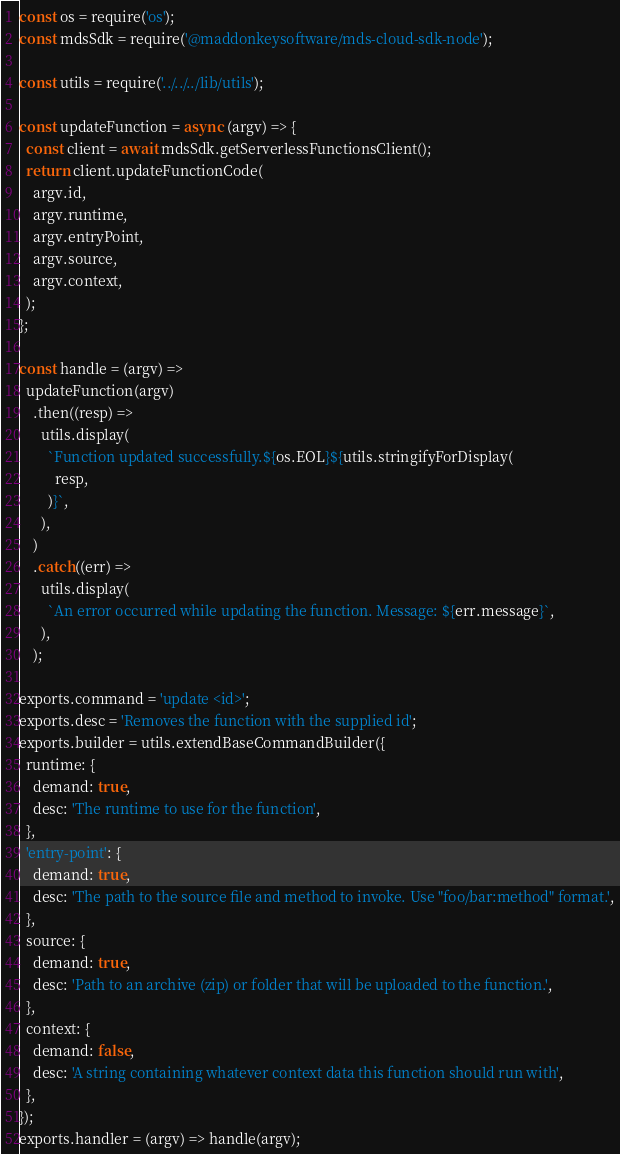<code> <loc_0><loc_0><loc_500><loc_500><_JavaScript_>const os = require('os');
const mdsSdk = require('@maddonkeysoftware/mds-cloud-sdk-node');

const utils = require('../../../lib/utils');

const updateFunction = async (argv) => {
  const client = await mdsSdk.getServerlessFunctionsClient();
  return client.updateFunctionCode(
    argv.id,
    argv.runtime,
    argv.entryPoint,
    argv.source,
    argv.context,
  );
};

const handle = (argv) =>
  updateFunction(argv)
    .then((resp) =>
      utils.display(
        `Function updated successfully.${os.EOL}${utils.stringifyForDisplay(
          resp,
        )}`,
      ),
    )
    .catch((err) =>
      utils.display(
        `An error occurred while updating the function. Message: ${err.message}`,
      ),
    );

exports.command = 'update <id>';
exports.desc = 'Removes the function with the supplied id';
exports.builder = utils.extendBaseCommandBuilder({
  runtime: {
    demand: true,
    desc: 'The runtime to use for the function',
  },
  'entry-point': {
    demand: true,
    desc: 'The path to the source file and method to invoke. Use "foo/bar:method" format.',
  },
  source: {
    demand: true,
    desc: 'Path to an archive (zip) or folder that will be uploaded to the function.',
  },
  context: {
    demand: false,
    desc: 'A string containing whatever context data this function should run with',
  },
});
exports.handler = (argv) => handle(argv);
</code> 